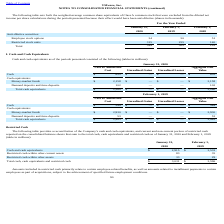According to Vmware's financial document, What do amounts included in restricted cash primarily relate to? certain employee-related benefits, as well as amounts related to installment payments to certain employees as part of acquisitions, subject to the achievement of specified future employment conditions.. The document states: "ts included in restricted cash primarily relate to certain employee-related benefits, as well as amounts related to installment payments to certain em..." Also, What was the amount of Restricted cash within other current assets in 2019? According to the financial document, 35 (in millions). The relevant text states: "Restricted cash within other current assets 83 35..." Also, What were the Total cash, cash equivalents and restricted cash in 2020? According to the financial document, 3,031 (in millions). The relevant text states: "otal cash, cash equivalents and restricted cash $ 3,031 $ 3,596..." Also, can you calculate: What was the change in Restricted cash within other assets between 2019 and 2020? Based on the calculation: 33-29, the result is 4 (in millions). This is based on the information: "Restricted cash within other assets 33 29 Restricted cash within other assets 33 29..." The key data points involved are: 29, 33. Also, can you calculate: What was the change in Restricted cash within other current assets between 2019 and 2020? Based on the calculation: 83-35, the result is 48 (in millions). This is based on the information: "Restricted cash within other current assets 83 35 Restricted cash within other current assets 83 35..." The key data points involved are: 35, 83. Also, can you calculate: What was the percentage change in the total cash, cash equivalents and restricted cash between 2019 and 2020? To answer this question, I need to perform calculations using the financial data. The calculation is: (3,031-3,596)/3,596, which equals -15.71 (percentage). This is based on the information: "otal cash, cash equivalents and restricted cash $ 3,031 $ 3,596 h, cash equivalents and restricted cash $ 3,031 $ 3,596..." The key data points involved are: 3,031, 3,596. 